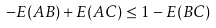Convert formula to latex. <formula><loc_0><loc_0><loc_500><loc_500>- E ( A B ) + E ( A C ) \leq 1 - E ( B C )</formula> 